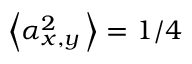Convert formula to latex. <formula><loc_0><loc_0><loc_500><loc_500>\left \langle \alpha _ { x , y } ^ { 2 } \, \right \rangle = 1 / 4</formula> 